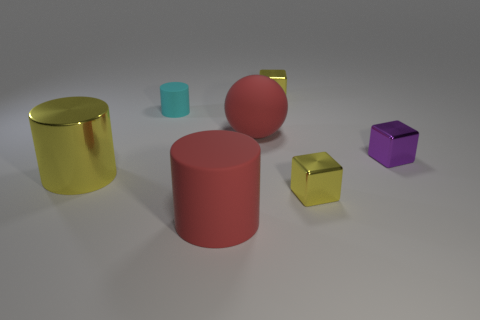Add 1 cubes. How many objects exist? 8 Subtract all cubes. How many objects are left? 4 Subtract 1 red spheres. How many objects are left? 6 Subtract all purple metallic objects. Subtract all yellow cubes. How many objects are left? 4 Add 6 cyan things. How many cyan things are left? 7 Add 6 big red objects. How many big red objects exist? 8 